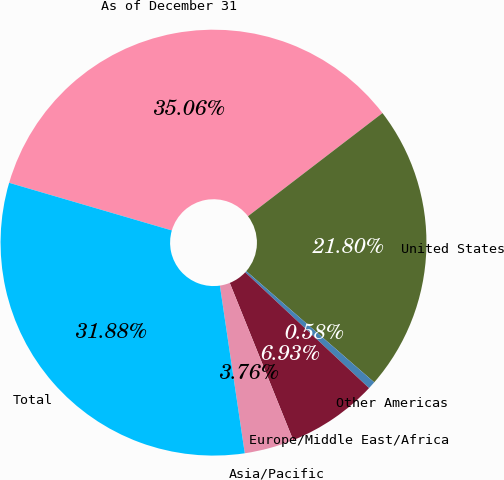Convert chart. <chart><loc_0><loc_0><loc_500><loc_500><pie_chart><fcel>As of December 31<fcel>United States<fcel>Other Americas<fcel>Europe/Middle East/Africa<fcel>Asia/Pacific<fcel>Total<nl><fcel>35.06%<fcel>21.8%<fcel>0.58%<fcel>6.93%<fcel>3.76%<fcel>31.88%<nl></chart> 